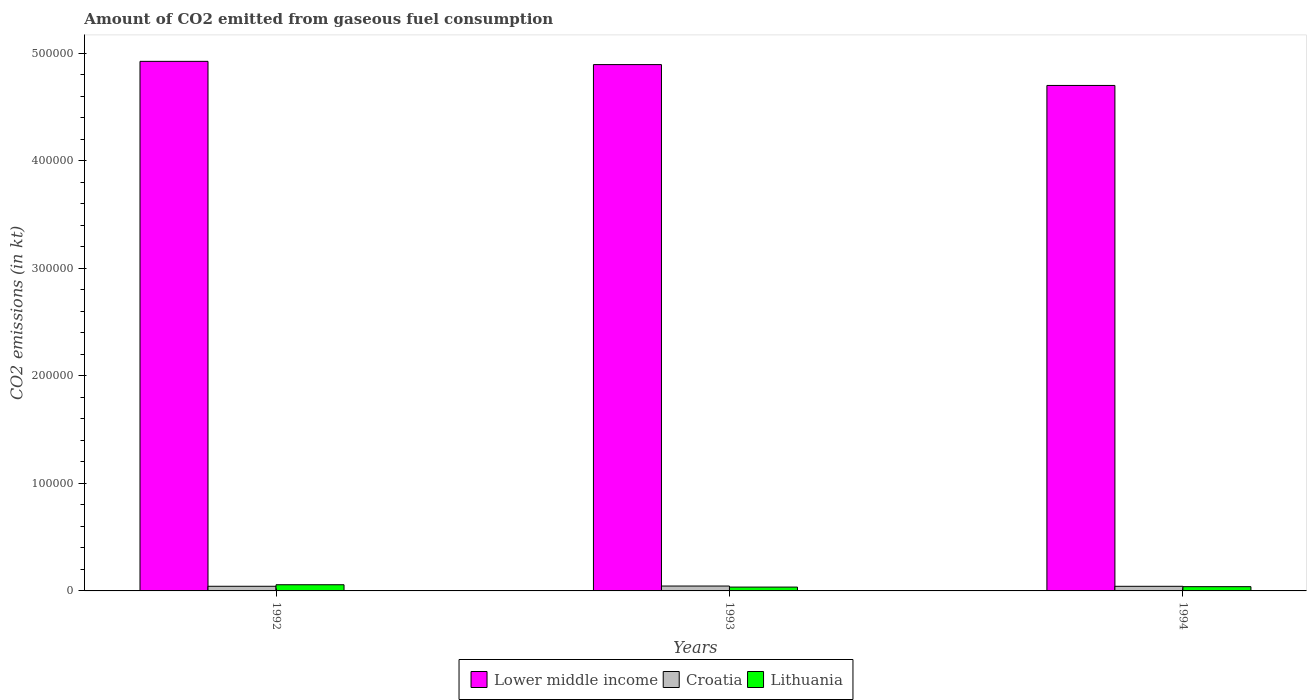Are the number of bars per tick equal to the number of legend labels?
Your answer should be compact. Yes. Are the number of bars on each tick of the X-axis equal?
Make the answer very short. Yes. How many bars are there on the 1st tick from the left?
Provide a succinct answer. 3. How many bars are there on the 3rd tick from the right?
Provide a succinct answer. 3. What is the amount of CO2 emitted in Croatia in 1992?
Give a very brief answer. 4316.06. Across all years, what is the maximum amount of CO2 emitted in Croatia?
Keep it short and to the point. 4547.08. Across all years, what is the minimum amount of CO2 emitted in Croatia?
Provide a succinct answer. 4290.39. In which year was the amount of CO2 emitted in Lower middle income maximum?
Make the answer very short. 1992. What is the total amount of CO2 emitted in Lithuania in the graph?
Ensure brevity in your answer.  1.33e+04. What is the difference between the amount of CO2 emitted in Lithuania in 1992 and that in 1994?
Your answer should be compact. 1782.16. What is the difference between the amount of CO2 emitted in Lower middle income in 1992 and the amount of CO2 emitted in Lithuania in 1994?
Provide a short and direct response. 4.89e+05. What is the average amount of CO2 emitted in Lower middle income per year?
Keep it short and to the point. 4.84e+05. In the year 1992, what is the difference between the amount of CO2 emitted in Lithuania and amount of CO2 emitted in Croatia?
Provide a succinct answer. 1430.13. In how many years, is the amount of CO2 emitted in Lithuania greater than 40000 kt?
Make the answer very short. 0. What is the ratio of the amount of CO2 emitted in Lower middle income in 1992 to that in 1994?
Your response must be concise. 1.05. Is the amount of CO2 emitted in Lithuania in 1992 less than that in 1993?
Your answer should be very brief. No. What is the difference between the highest and the second highest amount of CO2 emitted in Lithuania?
Your response must be concise. 1782.16. What is the difference between the highest and the lowest amount of CO2 emitted in Croatia?
Your answer should be compact. 256.69. What does the 1st bar from the left in 1994 represents?
Provide a short and direct response. Lower middle income. What does the 1st bar from the right in 1992 represents?
Provide a short and direct response. Lithuania. Is it the case that in every year, the sum of the amount of CO2 emitted in Lithuania and amount of CO2 emitted in Croatia is greater than the amount of CO2 emitted in Lower middle income?
Your response must be concise. No. How many bars are there?
Your answer should be compact. 9. Are all the bars in the graph horizontal?
Your answer should be compact. No. How many years are there in the graph?
Your answer should be compact. 3. Are the values on the major ticks of Y-axis written in scientific E-notation?
Your response must be concise. No. Does the graph contain any zero values?
Offer a very short reply. No. Does the graph contain grids?
Keep it short and to the point. No. How many legend labels are there?
Provide a short and direct response. 3. What is the title of the graph?
Provide a succinct answer. Amount of CO2 emitted from gaseous fuel consumption. What is the label or title of the Y-axis?
Provide a short and direct response. CO2 emissions (in kt). What is the CO2 emissions (in kt) of Lower middle income in 1992?
Provide a short and direct response. 4.93e+05. What is the CO2 emissions (in kt) in Croatia in 1992?
Make the answer very short. 4316.06. What is the CO2 emissions (in kt) of Lithuania in 1992?
Offer a very short reply. 5746.19. What is the CO2 emissions (in kt) in Lower middle income in 1993?
Your answer should be compact. 4.90e+05. What is the CO2 emissions (in kt) of Croatia in 1993?
Offer a terse response. 4547.08. What is the CO2 emissions (in kt) in Lithuania in 1993?
Give a very brief answer. 3571.66. What is the CO2 emissions (in kt) of Lower middle income in 1994?
Ensure brevity in your answer.  4.70e+05. What is the CO2 emissions (in kt) of Croatia in 1994?
Your response must be concise. 4290.39. What is the CO2 emissions (in kt) of Lithuania in 1994?
Make the answer very short. 3964.03. Across all years, what is the maximum CO2 emissions (in kt) in Lower middle income?
Provide a succinct answer. 4.93e+05. Across all years, what is the maximum CO2 emissions (in kt) of Croatia?
Your answer should be compact. 4547.08. Across all years, what is the maximum CO2 emissions (in kt) in Lithuania?
Give a very brief answer. 5746.19. Across all years, what is the minimum CO2 emissions (in kt) in Lower middle income?
Provide a succinct answer. 4.70e+05. Across all years, what is the minimum CO2 emissions (in kt) of Croatia?
Give a very brief answer. 4290.39. Across all years, what is the minimum CO2 emissions (in kt) in Lithuania?
Your response must be concise. 3571.66. What is the total CO2 emissions (in kt) in Lower middle income in the graph?
Your answer should be very brief. 1.45e+06. What is the total CO2 emissions (in kt) of Croatia in the graph?
Your response must be concise. 1.32e+04. What is the total CO2 emissions (in kt) in Lithuania in the graph?
Provide a short and direct response. 1.33e+04. What is the difference between the CO2 emissions (in kt) in Lower middle income in 1992 and that in 1993?
Your answer should be very brief. 3014.17. What is the difference between the CO2 emissions (in kt) in Croatia in 1992 and that in 1993?
Offer a very short reply. -231.02. What is the difference between the CO2 emissions (in kt) of Lithuania in 1992 and that in 1993?
Provide a short and direct response. 2174.53. What is the difference between the CO2 emissions (in kt) in Lower middle income in 1992 and that in 1994?
Provide a succinct answer. 2.24e+04. What is the difference between the CO2 emissions (in kt) of Croatia in 1992 and that in 1994?
Your answer should be compact. 25.67. What is the difference between the CO2 emissions (in kt) of Lithuania in 1992 and that in 1994?
Offer a very short reply. 1782.16. What is the difference between the CO2 emissions (in kt) in Lower middle income in 1993 and that in 1994?
Make the answer very short. 1.94e+04. What is the difference between the CO2 emissions (in kt) of Croatia in 1993 and that in 1994?
Provide a short and direct response. 256.69. What is the difference between the CO2 emissions (in kt) of Lithuania in 1993 and that in 1994?
Give a very brief answer. -392.37. What is the difference between the CO2 emissions (in kt) of Lower middle income in 1992 and the CO2 emissions (in kt) of Croatia in 1993?
Your answer should be very brief. 4.88e+05. What is the difference between the CO2 emissions (in kt) in Lower middle income in 1992 and the CO2 emissions (in kt) in Lithuania in 1993?
Provide a short and direct response. 4.89e+05. What is the difference between the CO2 emissions (in kt) in Croatia in 1992 and the CO2 emissions (in kt) in Lithuania in 1993?
Give a very brief answer. 744.4. What is the difference between the CO2 emissions (in kt) of Lower middle income in 1992 and the CO2 emissions (in kt) of Croatia in 1994?
Your answer should be compact. 4.88e+05. What is the difference between the CO2 emissions (in kt) in Lower middle income in 1992 and the CO2 emissions (in kt) in Lithuania in 1994?
Provide a succinct answer. 4.89e+05. What is the difference between the CO2 emissions (in kt) of Croatia in 1992 and the CO2 emissions (in kt) of Lithuania in 1994?
Ensure brevity in your answer.  352.03. What is the difference between the CO2 emissions (in kt) of Lower middle income in 1993 and the CO2 emissions (in kt) of Croatia in 1994?
Make the answer very short. 4.85e+05. What is the difference between the CO2 emissions (in kt) of Lower middle income in 1993 and the CO2 emissions (in kt) of Lithuania in 1994?
Make the answer very short. 4.86e+05. What is the difference between the CO2 emissions (in kt) in Croatia in 1993 and the CO2 emissions (in kt) in Lithuania in 1994?
Offer a very short reply. 583.05. What is the average CO2 emissions (in kt) in Lower middle income per year?
Your answer should be compact. 4.84e+05. What is the average CO2 emissions (in kt) in Croatia per year?
Make the answer very short. 4384.51. What is the average CO2 emissions (in kt) in Lithuania per year?
Give a very brief answer. 4427.29. In the year 1992, what is the difference between the CO2 emissions (in kt) of Lower middle income and CO2 emissions (in kt) of Croatia?
Your answer should be compact. 4.88e+05. In the year 1992, what is the difference between the CO2 emissions (in kt) in Lower middle income and CO2 emissions (in kt) in Lithuania?
Make the answer very short. 4.87e+05. In the year 1992, what is the difference between the CO2 emissions (in kt) of Croatia and CO2 emissions (in kt) of Lithuania?
Give a very brief answer. -1430.13. In the year 1993, what is the difference between the CO2 emissions (in kt) in Lower middle income and CO2 emissions (in kt) in Croatia?
Provide a succinct answer. 4.85e+05. In the year 1993, what is the difference between the CO2 emissions (in kt) of Lower middle income and CO2 emissions (in kt) of Lithuania?
Offer a very short reply. 4.86e+05. In the year 1993, what is the difference between the CO2 emissions (in kt) in Croatia and CO2 emissions (in kt) in Lithuania?
Offer a very short reply. 975.42. In the year 1994, what is the difference between the CO2 emissions (in kt) of Lower middle income and CO2 emissions (in kt) of Croatia?
Your response must be concise. 4.66e+05. In the year 1994, what is the difference between the CO2 emissions (in kt) of Lower middle income and CO2 emissions (in kt) of Lithuania?
Your answer should be compact. 4.66e+05. In the year 1994, what is the difference between the CO2 emissions (in kt) of Croatia and CO2 emissions (in kt) of Lithuania?
Offer a terse response. 326.36. What is the ratio of the CO2 emissions (in kt) of Croatia in 1992 to that in 1993?
Keep it short and to the point. 0.95. What is the ratio of the CO2 emissions (in kt) in Lithuania in 1992 to that in 1993?
Your answer should be very brief. 1.61. What is the ratio of the CO2 emissions (in kt) of Lower middle income in 1992 to that in 1994?
Ensure brevity in your answer.  1.05. What is the ratio of the CO2 emissions (in kt) in Lithuania in 1992 to that in 1994?
Provide a succinct answer. 1.45. What is the ratio of the CO2 emissions (in kt) in Lower middle income in 1993 to that in 1994?
Your response must be concise. 1.04. What is the ratio of the CO2 emissions (in kt) in Croatia in 1993 to that in 1994?
Your answer should be compact. 1.06. What is the ratio of the CO2 emissions (in kt) of Lithuania in 1993 to that in 1994?
Make the answer very short. 0.9. What is the difference between the highest and the second highest CO2 emissions (in kt) of Lower middle income?
Your answer should be compact. 3014.17. What is the difference between the highest and the second highest CO2 emissions (in kt) of Croatia?
Ensure brevity in your answer.  231.02. What is the difference between the highest and the second highest CO2 emissions (in kt) of Lithuania?
Your response must be concise. 1782.16. What is the difference between the highest and the lowest CO2 emissions (in kt) of Lower middle income?
Provide a succinct answer. 2.24e+04. What is the difference between the highest and the lowest CO2 emissions (in kt) of Croatia?
Make the answer very short. 256.69. What is the difference between the highest and the lowest CO2 emissions (in kt) of Lithuania?
Your response must be concise. 2174.53. 